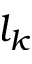<formula> <loc_0><loc_0><loc_500><loc_500>l _ { k }</formula> 